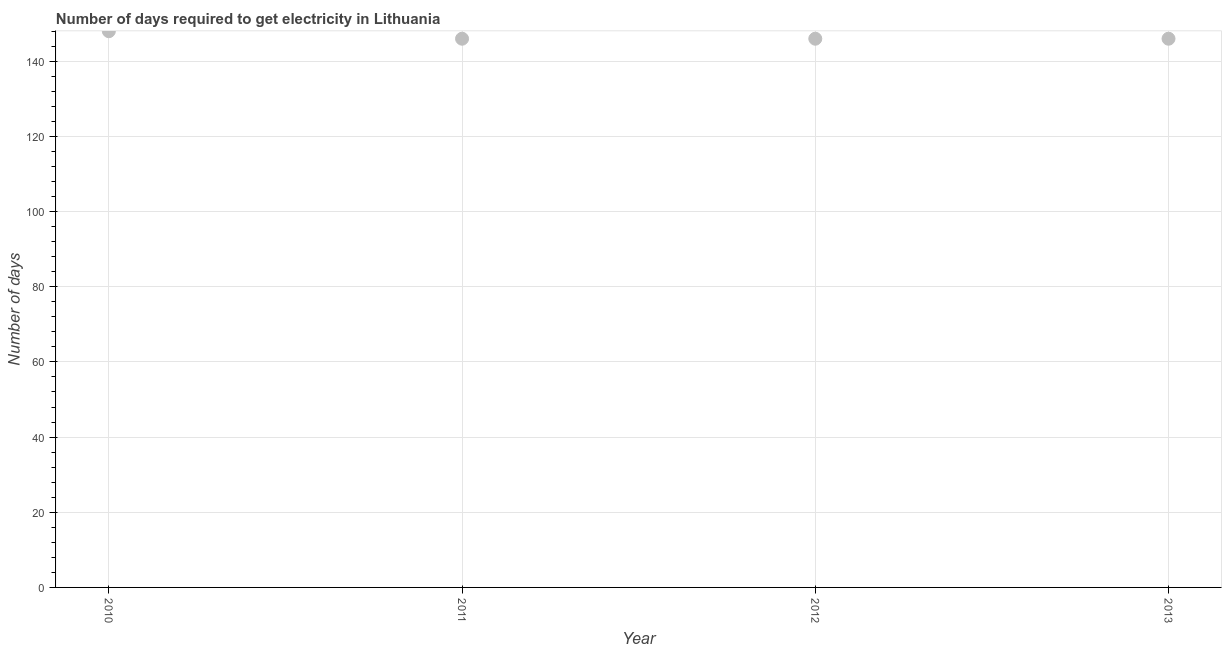What is the time to get electricity in 2013?
Give a very brief answer. 146. Across all years, what is the maximum time to get electricity?
Provide a succinct answer. 148. Across all years, what is the minimum time to get electricity?
Make the answer very short. 146. What is the sum of the time to get electricity?
Offer a terse response. 586. What is the difference between the time to get electricity in 2010 and 2011?
Your response must be concise. 2. What is the average time to get electricity per year?
Ensure brevity in your answer.  146.5. What is the median time to get electricity?
Provide a short and direct response. 146. What is the ratio of the time to get electricity in 2010 to that in 2011?
Your answer should be compact. 1.01. Is the time to get electricity in 2010 less than that in 2013?
Provide a succinct answer. No. Is the difference between the time to get electricity in 2012 and 2013 greater than the difference between any two years?
Provide a succinct answer. No. What is the difference between the highest and the second highest time to get electricity?
Make the answer very short. 2. Is the sum of the time to get electricity in 2011 and 2013 greater than the maximum time to get electricity across all years?
Ensure brevity in your answer.  Yes. What is the difference between the highest and the lowest time to get electricity?
Offer a very short reply. 2. In how many years, is the time to get electricity greater than the average time to get electricity taken over all years?
Offer a terse response. 1. Does the time to get electricity monotonically increase over the years?
Your response must be concise. No. How many years are there in the graph?
Ensure brevity in your answer.  4. Are the values on the major ticks of Y-axis written in scientific E-notation?
Your answer should be compact. No. Does the graph contain grids?
Your response must be concise. Yes. What is the title of the graph?
Offer a very short reply. Number of days required to get electricity in Lithuania. What is the label or title of the Y-axis?
Your answer should be very brief. Number of days. What is the Number of days in 2010?
Your response must be concise. 148. What is the Number of days in 2011?
Ensure brevity in your answer.  146. What is the Number of days in 2012?
Your answer should be compact. 146. What is the Number of days in 2013?
Make the answer very short. 146. What is the difference between the Number of days in 2010 and 2011?
Your response must be concise. 2. What is the difference between the Number of days in 2011 and 2012?
Ensure brevity in your answer.  0. What is the ratio of the Number of days in 2010 to that in 2011?
Offer a terse response. 1.01. What is the ratio of the Number of days in 2010 to that in 2012?
Your answer should be compact. 1.01. What is the ratio of the Number of days in 2011 to that in 2012?
Ensure brevity in your answer.  1. 